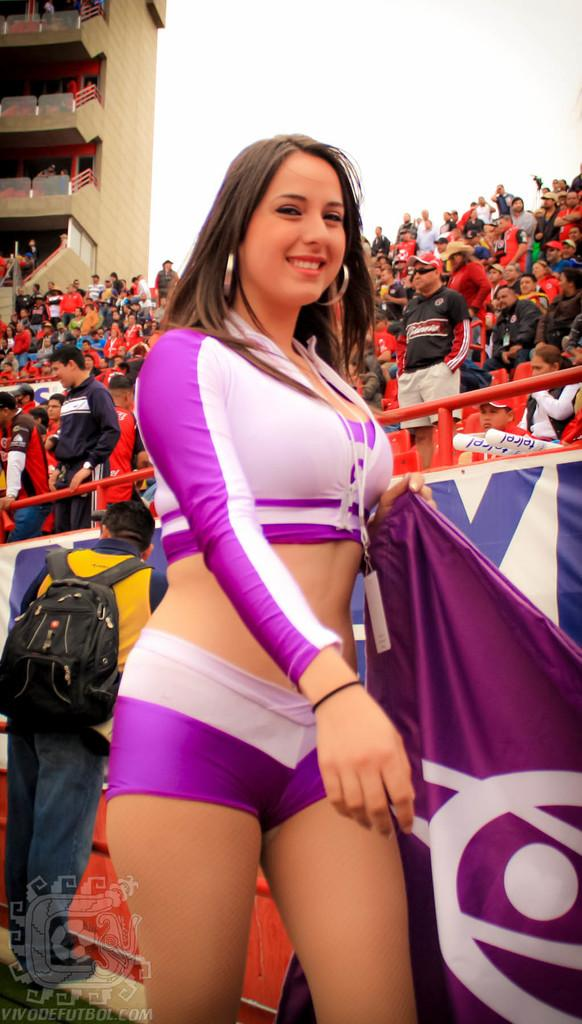What is the main subject of the image? There is a woman standing in the center of the image. What is the woman holding in the image? The woman is holding a flag. What can be seen in the background of the image? There is a fencing, a crowd, a building, and the sky visible in the background of the image. What type of zebra can be seen in the image? There is no zebra present in the image. What date is marked on the calendar in the image? There is no calendar present in the image. 